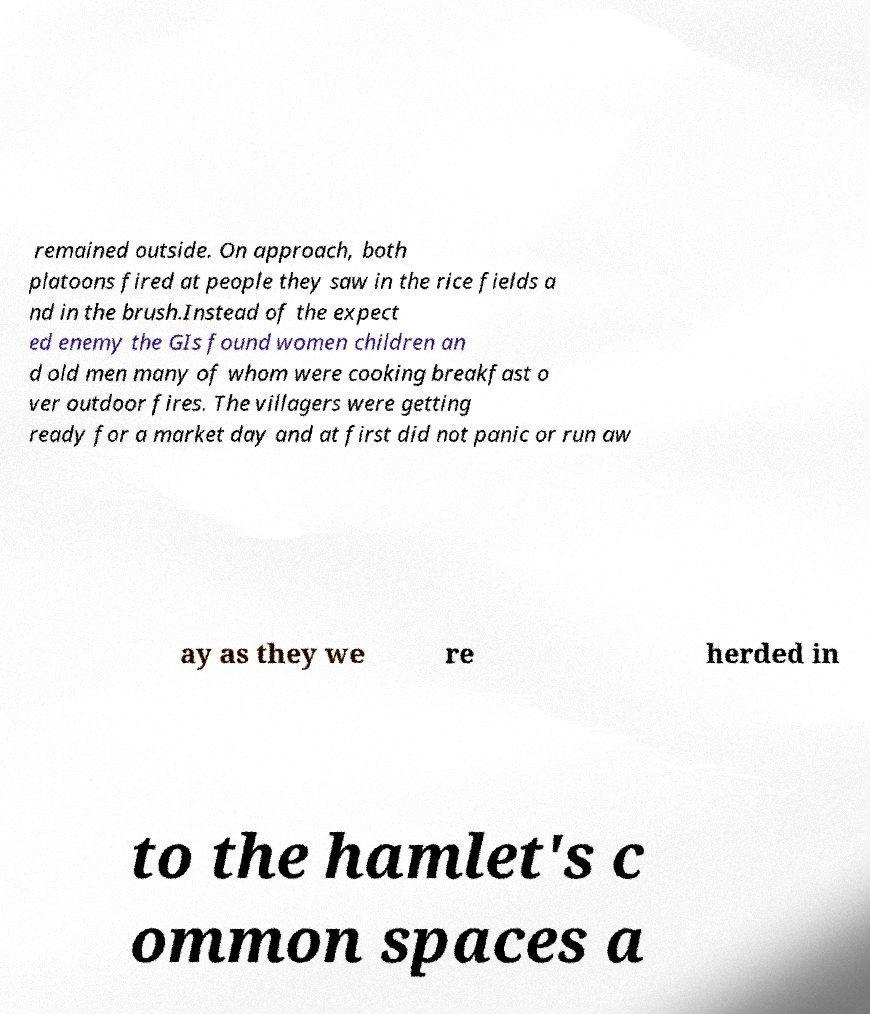Could you assist in decoding the text presented in this image and type it out clearly? remained outside. On approach, both platoons fired at people they saw in the rice fields a nd in the brush.Instead of the expect ed enemy the GIs found women children an d old men many of whom were cooking breakfast o ver outdoor fires. The villagers were getting ready for a market day and at first did not panic or run aw ay as they we re herded in to the hamlet's c ommon spaces a 